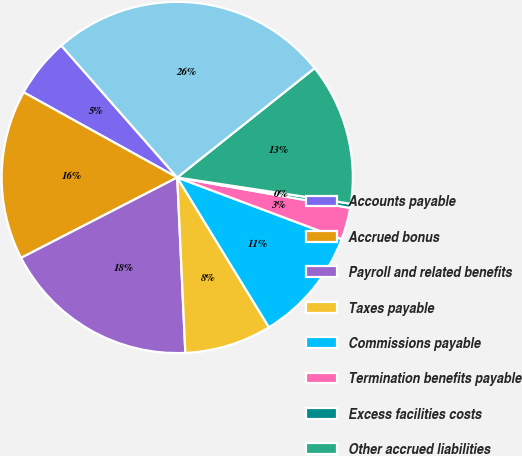Convert chart. <chart><loc_0><loc_0><loc_500><loc_500><pie_chart><fcel>Accounts payable<fcel>Accrued bonus<fcel>Payroll and related benefits<fcel>Taxes payable<fcel>Commissions payable<fcel>Termination benefits payable<fcel>Excess facilities costs<fcel>Other accrued liabilities<fcel>Total accounts payable and<nl><fcel>5.47%<fcel>15.63%<fcel>18.17%<fcel>8.01%<fcel>10.55%<fcel>2.93%<fcel>0.39%<fcel>13.09%<fcel>25.78%<nl></chart> 